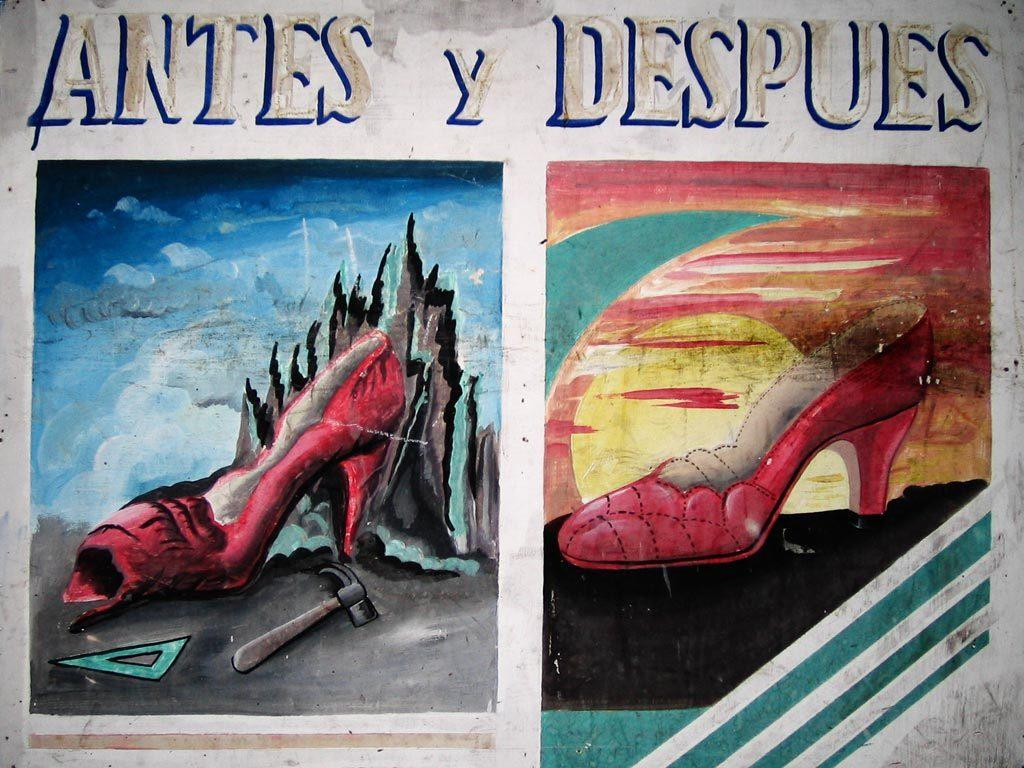What is depicted in the painting in the image? There is a painting of a shoe and a painting of a hammer in the image. Are there any other objects in the painting? Yes, there is another object in the painting. What is located beside the painting? There is another shoe beside the painting. Who is present in the image? There is a son in the image. What can be seen at the top of the image? There is some text at the top of the image. What arithmetic problem is the son solving in the image? There is no arithmetic problem visible in the image; the son is not shown performing any calculations or solving any equations. What type of pencil is the son using to draw the painting? There is no pencil visible in the image, and the son is not shown drawing the painting. 